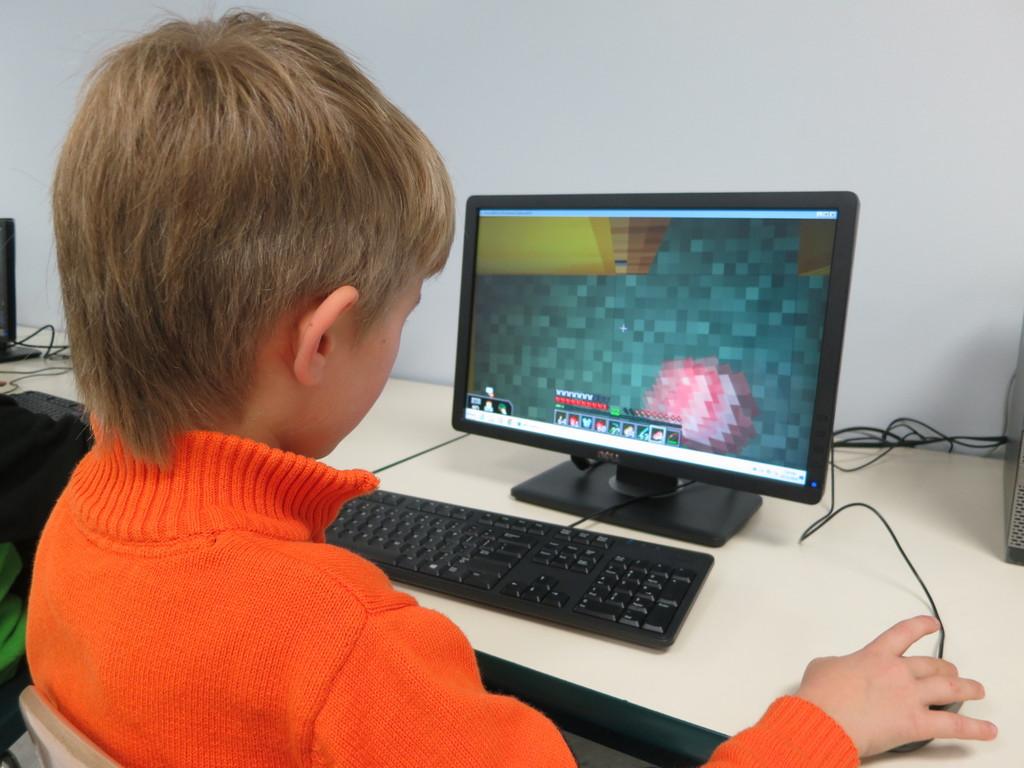What type of monitor is he using?
Ensure brevity in your answer.  Dell. 